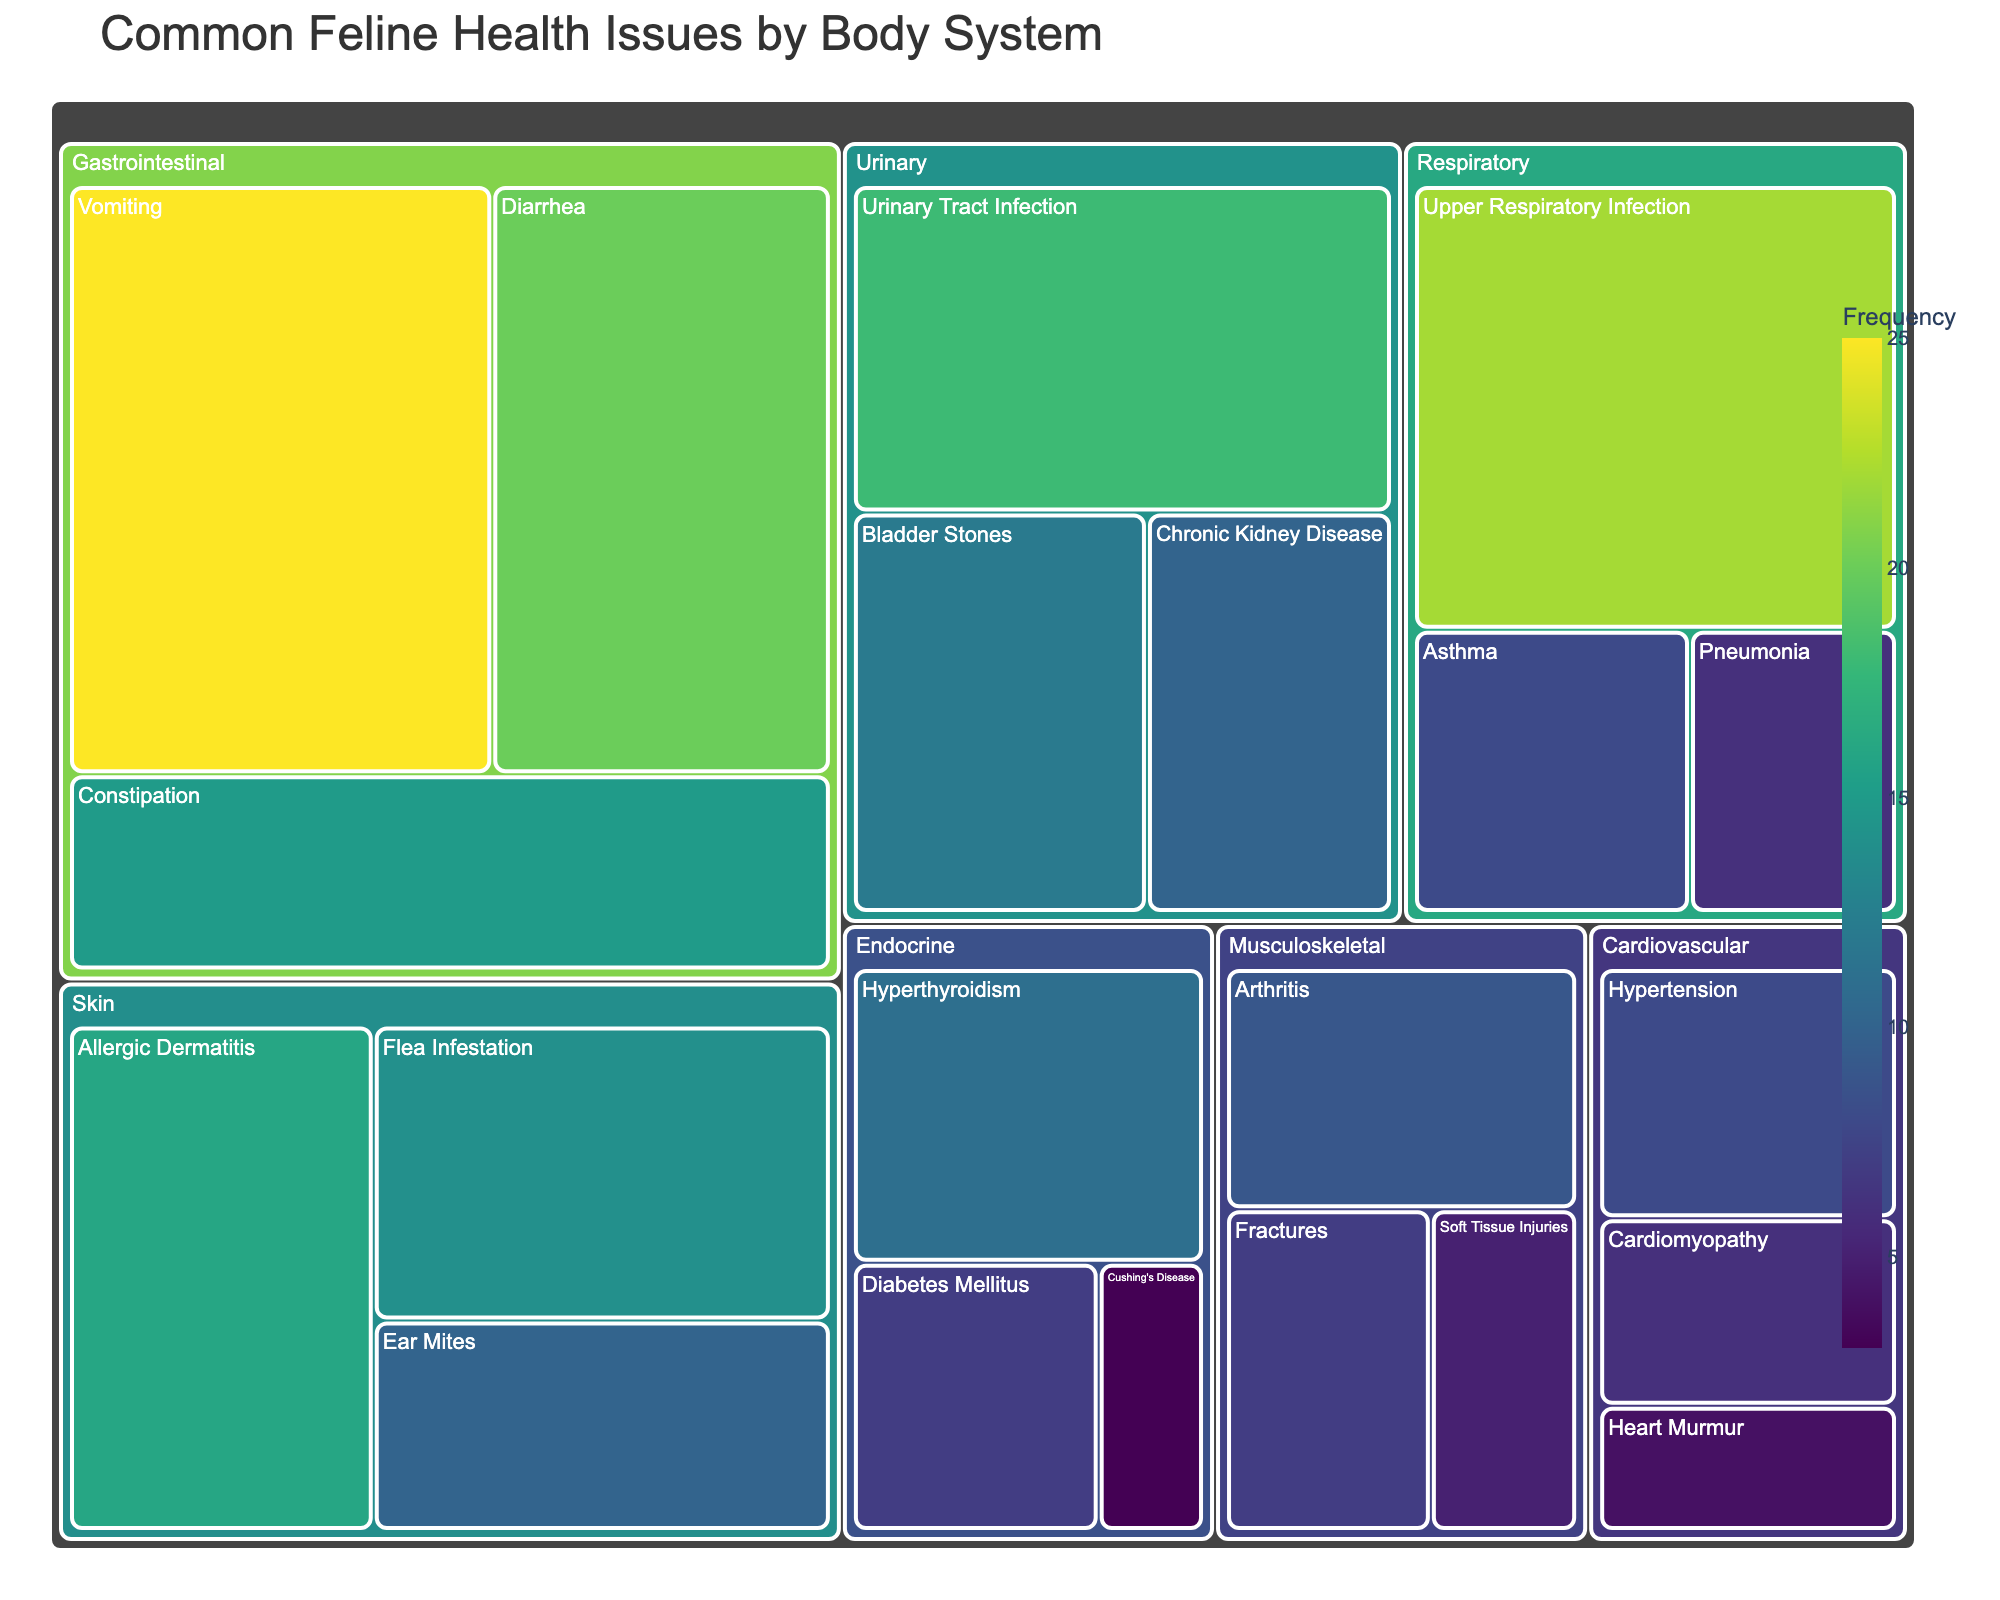What's the title of the treemap? The title is the main text at the top of the treemap that provides an overview of what the visual represents.
Answer: Common Feline Health Issues by Body System Which body system has the highest number of health issues in total? To find the body system with the highest number of health issues, look for the category with the largest combined frequency values in the treemap. This involves adding the frequencies of all health issues under each body system and comparing them. Gastrointestinal: (25+20+15)=60, Urinary: (18+12+10)=40, Respiratory: (22+8+6)=36, Skin: (16+14+10)=40, Musculoskeletal: (9+7+5)=21, Cardiovascular: (8+6+4)=18, Endocrine: (11+7+3)=21. Gastrointestinal has the highest cumulative frequency.
Answer: Gastrointestinal What is the frequency of the most common health issue in the Respiratory system? Look under the Respiratory system section and identify the health issue with the highest frequency value. Upper Respiratory Infection has a frequency of 22.
Answer: 22 Which health issue in the Skin category has the lowest frequency? Inspect the Skin section of the treemap and identify the health issue with the smallest frequency value. Ear Mites has a frequency of 10.
Answer: Ear Mites How do the frequencies of Vomiting and Diarrhea compare? Check the frequencies of Vomiting (25) and Diarrhea (20) in the Gastrointestinal category and compare them. Vomiting has a higher frequency than Diarrhea.
Answer: Vomiting has a higher frequency than Diarrhea What is the combined frequency of Urinary Tract Infection and Bladder Stones? To find the combined frequency, sum the values for Urinary Tract Infection (18) and Bladder Stones (12). The total is 18 + 12 = 30.
Answer: 30 Which body system has fewer health issues: Cardiovascular or Musculoskeletal? Compare the number of health issues listed under the Cardiovascular system (3) and the Musculoskeletal system (3). Both systems have the same number of health issues.
Answer: They have the same number of health issues What is the frequency of Hyperthyroidism in the Endocrine system? Locate the Endocrine system section and check the frequency value for Hyperthyroidism.
Answer: 11 Which health issue in the Gastrointestinal system has the lowest frequency? Look in the Gastrointestinal section and identify the health issue with the smallest frequency value. Constipation has a frequency of 15.
Answer: Constipation 